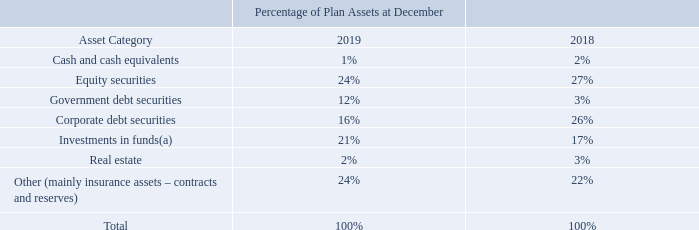The Company’s pension plan asset allocation at December 31, 2019 and at December 31, 2018 is as follows:
As of December 31, 2019, investments in funds were composed of commingled and multi-strategy funds invested in diversified portfolios of corporate bonds (37%), government bonds (32%), equity (15%) and other instruments (16%).
As of December 31, 2018, investments in funds were composed approximately for two thirds of commingled funds mainly invested in corporate bonds (55%) and treasury bonds and notes (45%) and for one third of multi-strategy funds invested in broadly diversified portfolios of
corporate and government bonds, equity and derivative instruments.
What were the investments composed of as of December 31, 2019? Commingled and multi-strategy funds invested in diversified portfolios of corporate bonds (37%), government bonds (32%), equity (15%) and other instruments (16%). What was the percentage of investment in corporate bonds as of December 31, 2018? 55%. What was the percentage of investment in treasury bonds and notes in 2018? 45%. What was the average investment in cash and cash equivalents?
Answer scale should be: percent. (2% + 1%) / 2
Answer: 1.5. What was the increase / (decrease) in the investment in Equity Securities from 2018 to 2019?
Answer scale should be: percent. 24% - 27%
Answer: -3. What was the increase / (decrease) in the Real estate from 2018 to 2019?
Answer scale should be: percent. 2% - 3%
Answer: -1. 